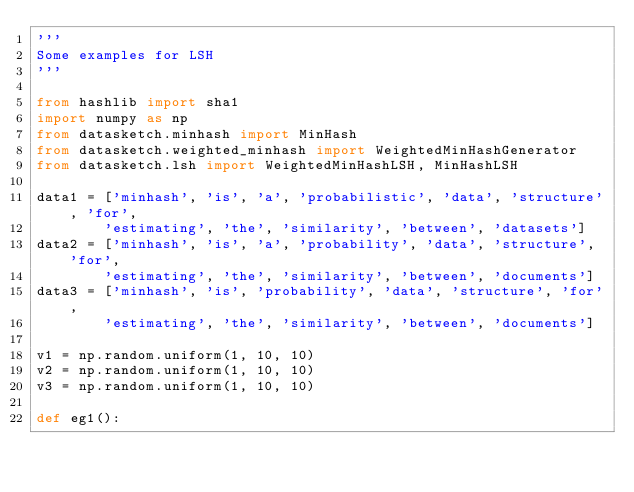Convert code to text. <code><loc_0><loc_0><loc_500><loc_500><_Python_>'''
Some examples for LSH
'''

from hashlib import sha1
import numpy as np
from datasketch.minhash import MinHash
from datasketch.weighted_minhash import WeightedMinHashGenerator
from datasketch.lsh import WeightedMinHashLSH, MinHashLSH

data1 = ['minhash', 'is', 'a', 'probabilistic', 'data', 'structure', 'for',
        'estimating', 'the', 'similarity', 'between', 'datasets']
data2 = ['minhash', 'is', 'a', 'probability', 'data', 'structure', 'for',
        'estimating', 'the', 'similarity', 'between', 'documents']
data3 = ['minhash', 'is', 'probability', 'data', 'structure', 'for',
        'estimating', 'the', 'similarity', 'between', 'documents']

v1 = np.random.uniform(1, 10, 10)
v2 = np.random.uniform(1, 10, 10)
v3 = np.random.uniform(1, 10, 10)

def eg1():</code> 